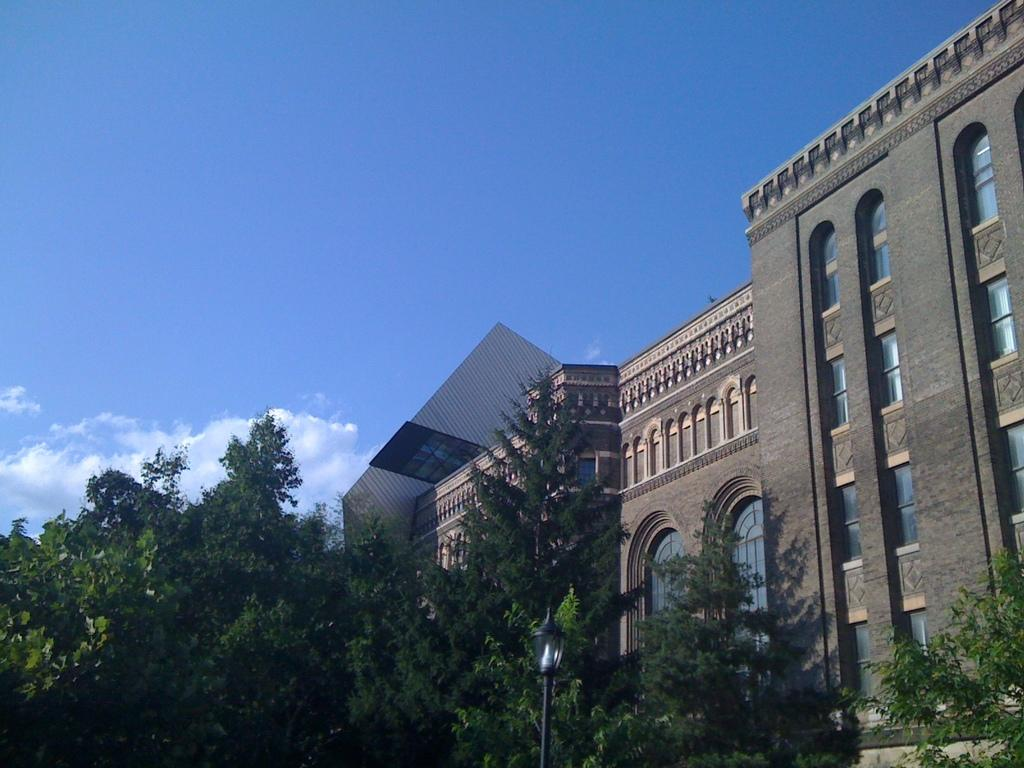What type of structure is visible in the image? There is a building in the image. What other objects can be seen in the image? There are trees and a street light in front of the building. What is visible in the background of the image? The sky is visible in the background of the image. What can be observed in the sky? Clouds are present in the sky. Can you see a donkey walking down the street in the image? No, there is no donkey or street visible in the image. Is there a servant holding a mitten near the building? No, there is no servant or mitten present in the image. 